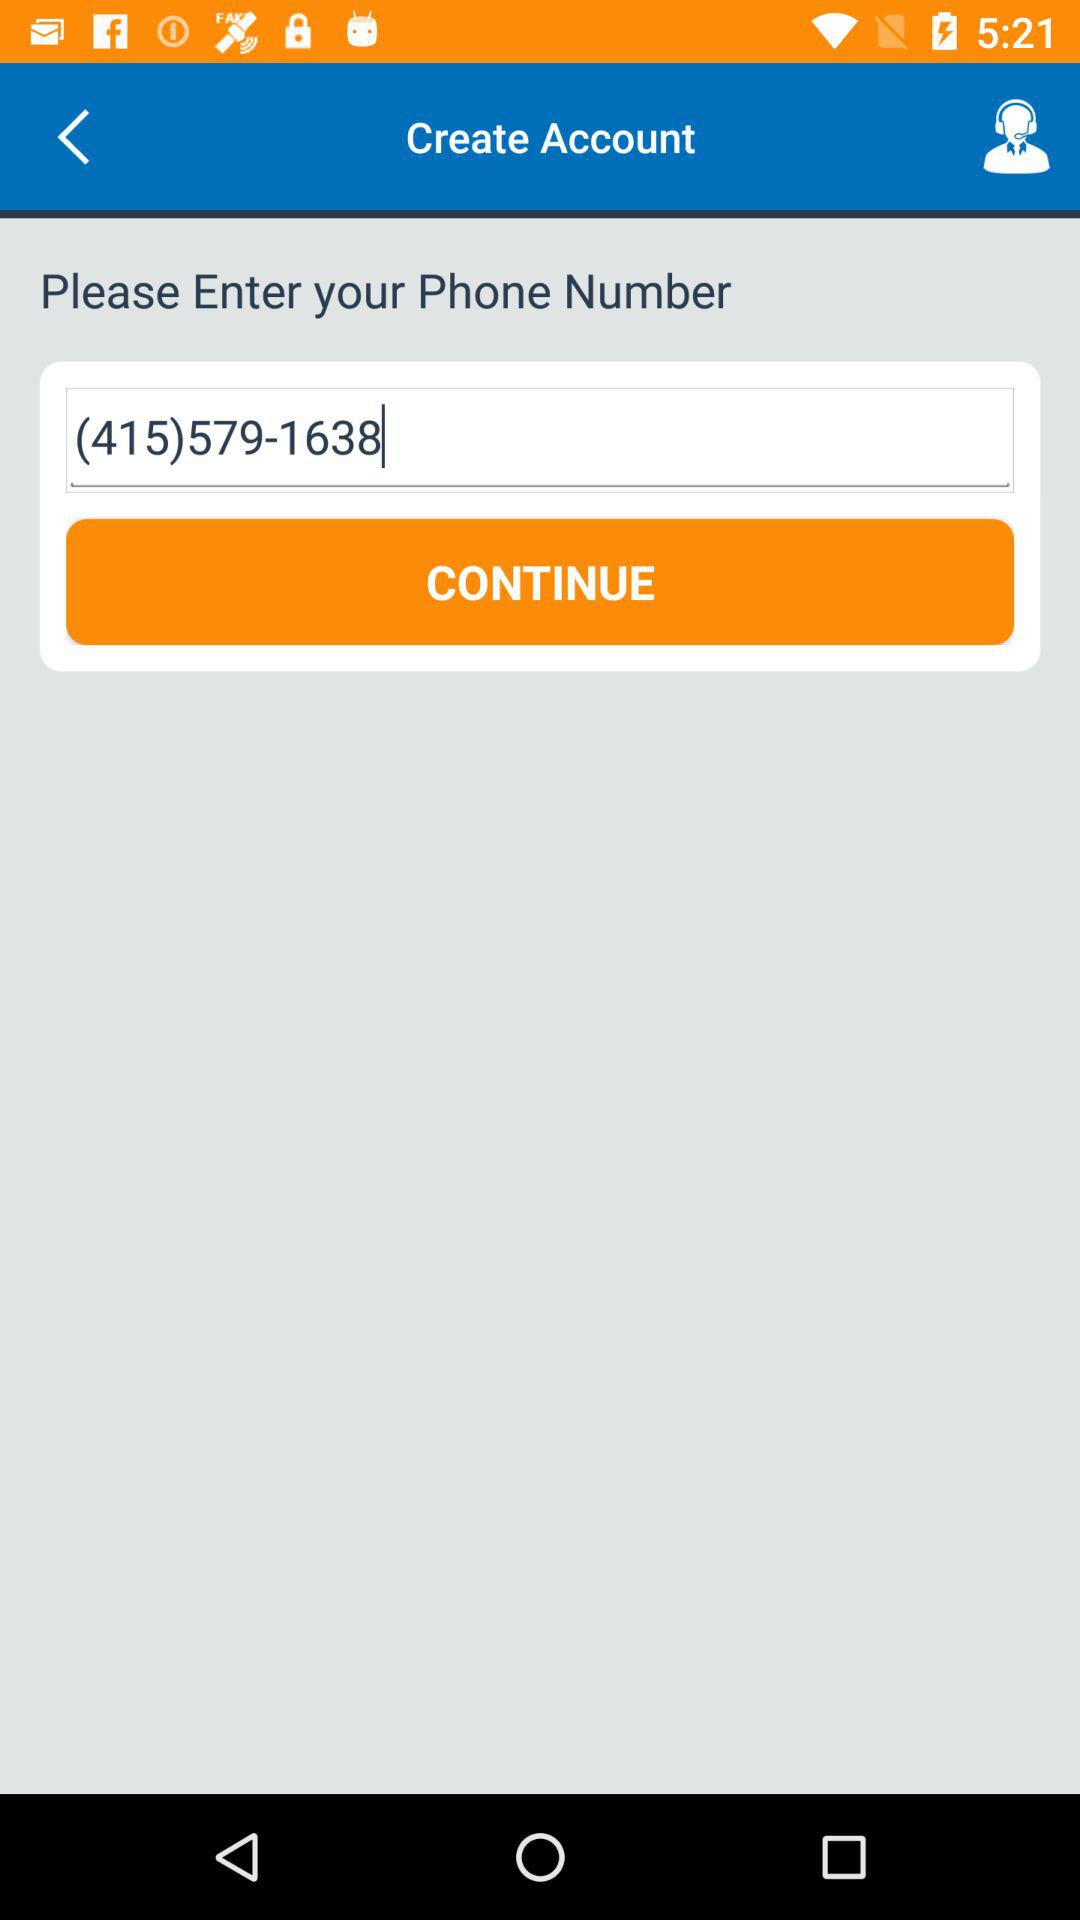What is the phone number? The phone number is (415)579-1638. 